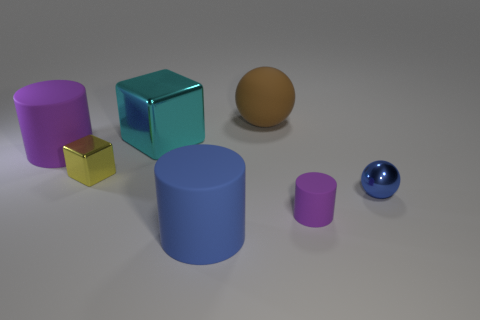Is there any other thing that has the same color as the big block?
Offer a terse response. No. Are the big cylinder in front of the blue metal object and the small yellow object made of the same material?
Provide a succinct answer. No. What number of large objects are to the right of the big cyan shiny thing and in front of the large sphere?
Make the answer very short. 1. There is a purple matte cylinder that is right of the large brown ball that is to the left of the small blue shiny thing; what is its size?
Ensure brevity in your answer.  Small. Are there more yellow shiny things than small brown balls?
Ensure brevity in your answer.  Yes. There is a ball in front of the big cyan block; does it have the same color as the big rubber cylinder on the right side of the big cyan metal block?
Your response must be concise. Yes. There is a purple matte cylinder to the right of the large brown object; are there any objects that are to the left of it?
Keep it short and to the point. Yes. Is the number of metallic objects on the left side of the small blue metal sphere less than the number of rubber objects that are in front of the large brown rubber object?
Provide a succinct answer. Yes. Is the blue object on the left side of the small blue shiny ball made of the same material as the small thing behind the small ball?
Ensure brevity in your answer.  No. What number of tiny things are either blue matte cylinders or spheres?
Provide a succinct answer. 1. 